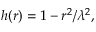Convert formula to latex. <formula><loc_0><loc_0><loc_500><loc_500>h ( r ) = 1 - r ^ { 2 } / \lambda ^ { 2 } ,</formula> 